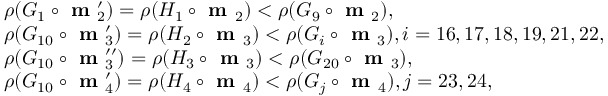Convert formula to latex. <formula><loc_0><loc_0><loc_500><loc_500>\begin{array} { r l } & { \rho ( G _ { 1 } \circ m _ { 2 } ^ { \prime } ) = \rho ( H _ { 1 } \circ m _ { 2 } ) < \rho ( G _ { 9 } \circ m _ { 2 } ) , } \\ & { \rho ( G _ { 1 0 } \circ m _ { 3 } ^ { \prime } ) = \rho ( H _ { 2 } \circ m _ { 3 } ) < \rho ( G _ { i } \circ m _ { 3 } ) , i = 1 6 , 1 7 , 1 8 , 1 9 , 2 1 , 2 2 , } \\ & { \rho ( G _ { 1 0 } \circ m _ { 3 } ^ { \prime \prime } ) = \rho ( H _ { 3 } \circ m _ { 3 } ) < \rho ( G _ { 2 0 } \circ m _ { 3 } ) , } \\ & { \rho ( G _ { 1 0 } \circ m _ { 4 } ^ { \prime } ) = \rho ( H _ { 4 } \circ m _ { 4 } ) < \rho ( G _ { j } \circ m _ { 4 } ) , j = 2 3 , 2 4 , } \end{array}</formula> 